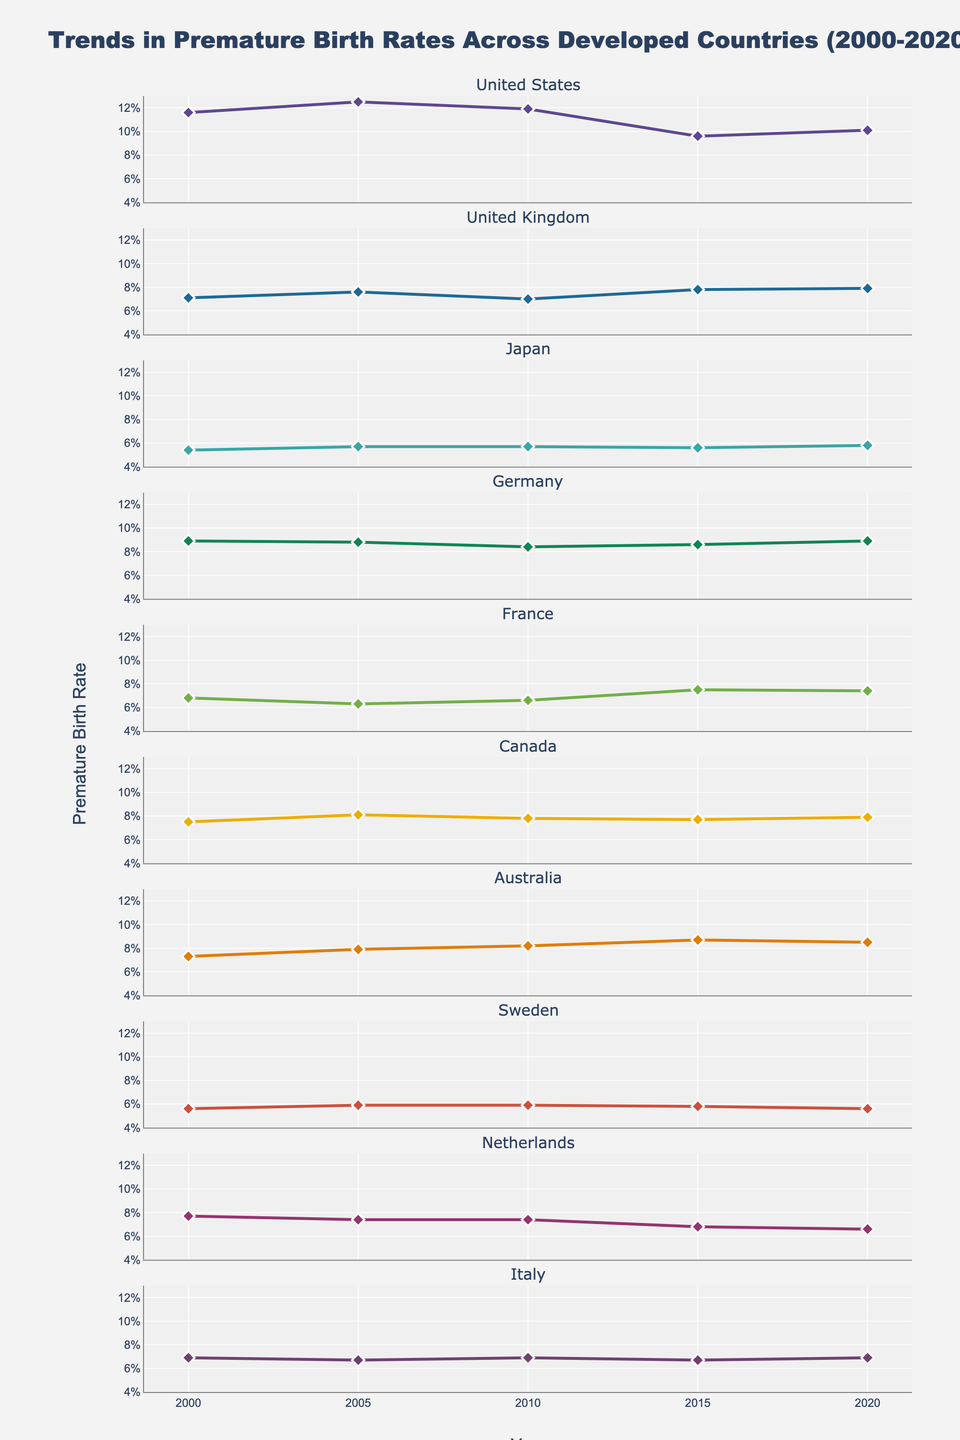Which country had the highest premature birth rate in 2005? Look for the year 2005 on the x-axis and identify the country with the highest y-value. The United States shows a peak at 12.5%.
Answer: The United States How did the premature birth rate trend for Canada change from 2005 to 2020? Identify the plot line for Canada. In 2005, the rate is 8.1% and in 2020, it is 7.9%. The trend shows a slight decrease.
Answer: Slightly decreased What is the average premature birth rate in the United Kingdom over the two decades shown? First, collect the rates for the United Kingdom: 7.1, 7.6, 7.0, 7.8, 7.9. Sum these values (37.4) and divide by 5 (number of years) to get the average.
Answer: 7.48% Which country had the lowest premature birth rate in 2010? Check the year 2010 across all subplots and find the lowest y-value. Japan has the lowest value at 5.7%.
Answer: Japan Compare the trends of premature birth rates in Germany and the Netherlands from 2000 to 2020. Which country shows a clearer increase or decrease? Observe both subplots. Germany's rates vary slightly around 8.5%, showing little change, while the Netherlands shows a decrease from 7.7% to 6.6%. The Netherlands shows a clearer decrease.
Answer: The Netherlands In which year did Australia experience its highest premature birth rate? Look at the Australian subplot and identify the year with the highest y-value. It's in 2015 with a rate of 8.7%.
Answer: 2015 Between Japan and Sweden, which country had a more stable premature birth rate trend? Compare the fluctuations in the subplots for Japan and Sweden. Japan's rates are around 5.6-5.8% with minimal fluctuation, while Sweden has similar rates but with a clearer fluctuation around 5.9%.
Answer: Japan What is the general trend of premature birth rates in France from 2000 to 2020? Examine the France subplot. The rate decreases from 6.8% to 6.3% in 2005, increases to 7.5% in 2015, and slightly decreases to 7.4% in 2020.
Answer: Variable with an overall increase Which country showed the greatest improvement in reducing premature birth rates from 2010 to 2020? Compare countries' rates from 2010 to 2020. The United States shows the most significant reduction from 11.9% to 10.1%.
Answer: The United States 